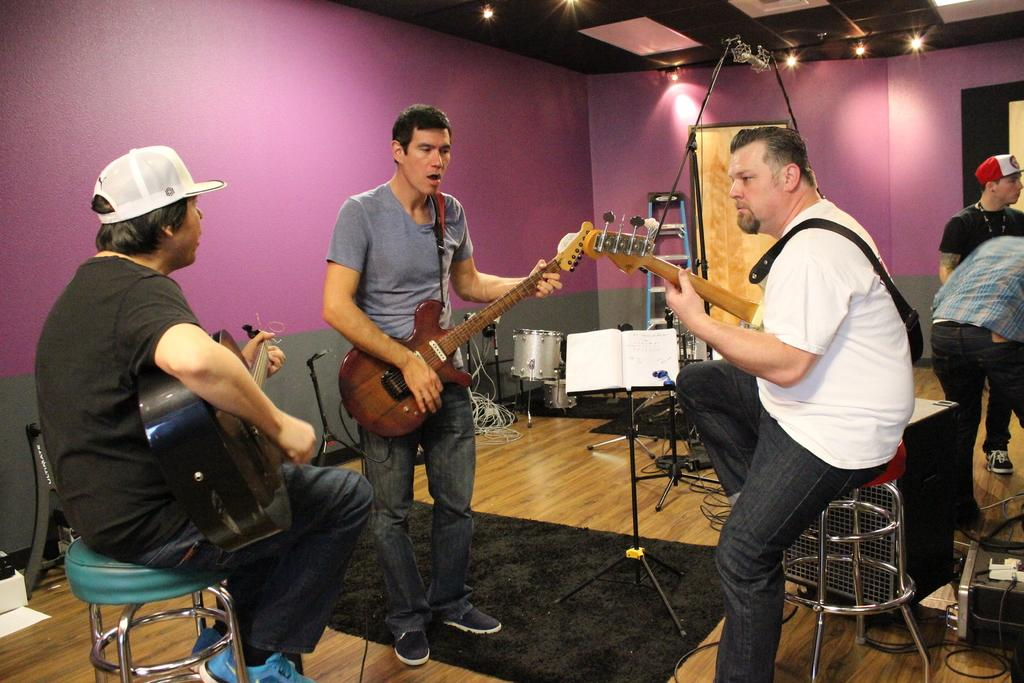What are the three men in the image doing? The three men are playing guitar and singing. How are the two men who are playing guitar positioned? Two of the men are sitting on stools. What are the other two men in the image doing? The other two men are standing aside. What else can be seen in the background of the image? There are other musical instruments in the background. What type of beetle can be seen crawling on the guitar in the image? There is no beetle present in the image; it only features the three men playing guitar and singing, along with the other two men standing aside and the musical instruments in the background. 